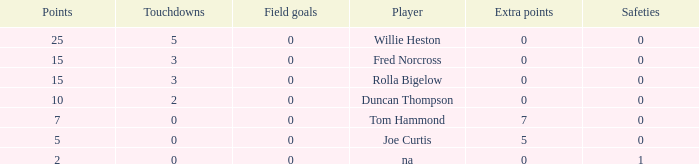How many Touchdowns have a Player of rolla bigelow, and an Extra points smaller than 0? None. 